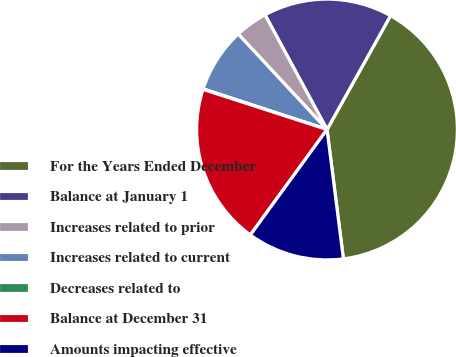Convert chart. <chart><loc_0><loc_0><loc_500><loc_500><pie_chart><fcel>For the Years Ended December<fcel>Balance at January 1<fcel>Increases related to prior<fcel>Increases related to current<fcel>Decreases related to<fcel>Balance at December 31<fcel>Amounts impacting effective<nl><fcel>39.9%<fcel>15.99%<fcel>4.04%<fcel>8.03%<fcel>0.06%<fcel>19.98%<fcel>12.01%<nl></chart> 